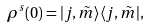<formula> <loc_0><loc_0><loc_500><loc_500>\rho ^ { s } ( 0 ) = | j , \tilde { m } \rangle \langle j , \tilde { m } | ,</formula> 